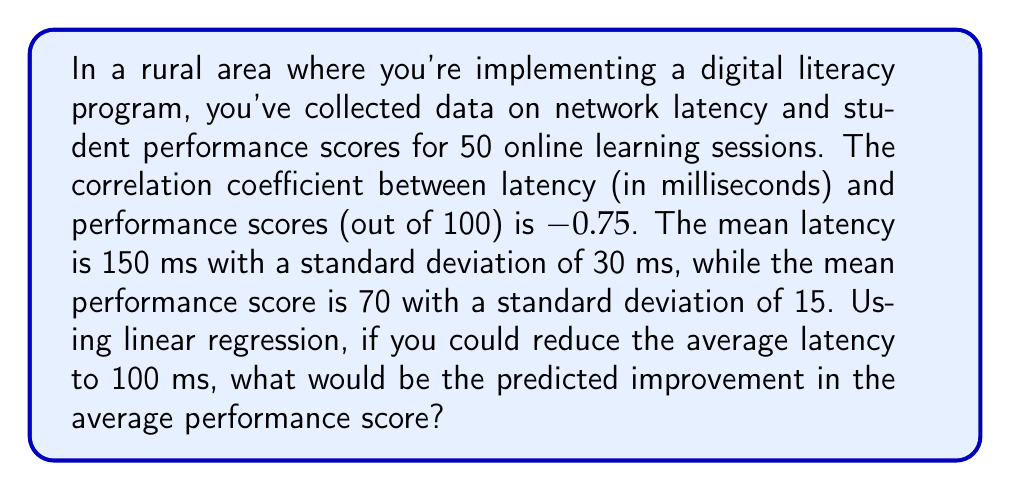Show me your answer to this math problem. Let's approach this step-by-step using linear regression:

1) First, recall the formula for the slope (b) in a linear regression:
   $$b = r \frac{s_y}{s_x}$$
   where r is the correlation coefficient, $s_y$ is the standard deviation of y (performance scores), and $s_x$ is the standard deviation of x (latency).

2) Calculate the slope:
   $$b = -0.75 \frac{15}{30} = -0.375$$

3) The linear regression equation is:
   $$y = a + bx$$
   where y is the performance score, x is the latency, and a is the y-intercept.

4) We can find the y-intercept using the means:
   $$70 = a + (-0.375 * 150)$$
   $$a = 70 + 56.25 = 126.25$$

5) So our regression equation is:
   $$y = 126.25 - 0.375x$$

6) If we reduce latency from 150 ms to 100 ms, that's a reduction of 50 ms.

7) The predicted improvement would be:
   $$\text{Improvement} = 0.375 * 50 = 18.75$$

Therefore, reducing the average latency to 100 ms is predicted to improve the average performance score by 18.75 points.
Answer: 18.75 points 